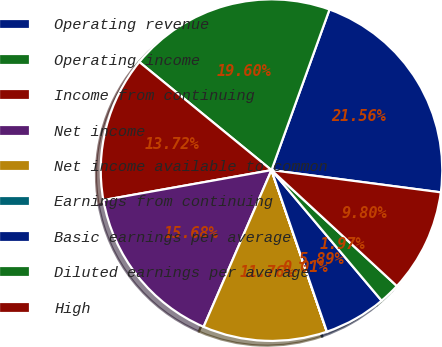<chart> <loc_0><loc_0><loc_500><loc_500><pie_chart><fcel>Operating revenue<fcel>Operating income<fcel>Income from continuing<fcel>Net income<fcel>Net income available to common<fcel>Earnings from continuing<fcel>Basic earnings per average<fcel>Diluted earnings per average<fcel>High<nl><fcel>21.56%<fcel>19.6%<fcel>13.72%<fcel>15.68%<fcel>11.76%<fcel>0.01%<fcel>5.89%<fcel>1.97%<fcel>9.8%<nl></chart> 